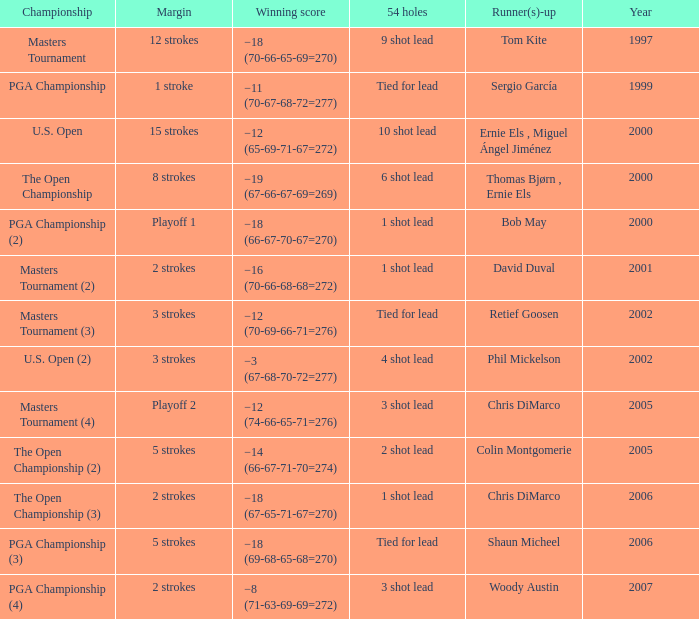 who is the runner(s)-up where 54 holes is tied for lead and margin is 5 strokes Shaun Micheel. 